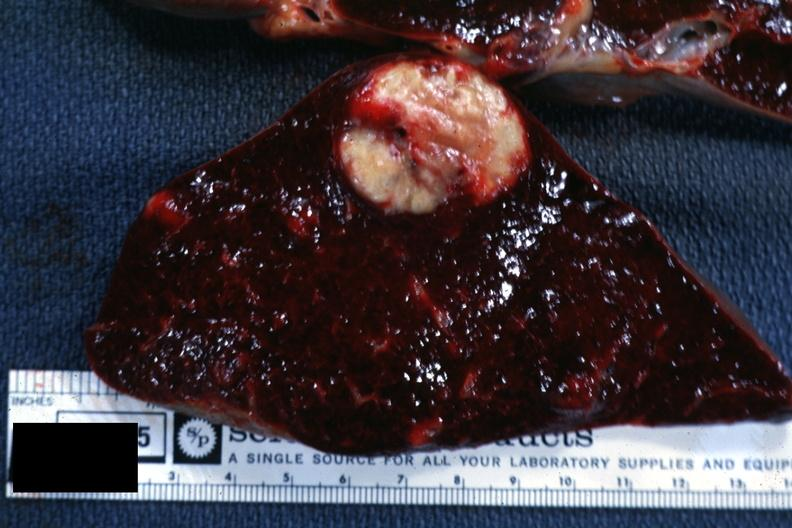s mixed mesodermal tumor present?
Answer the question using a single word or phrase. No 